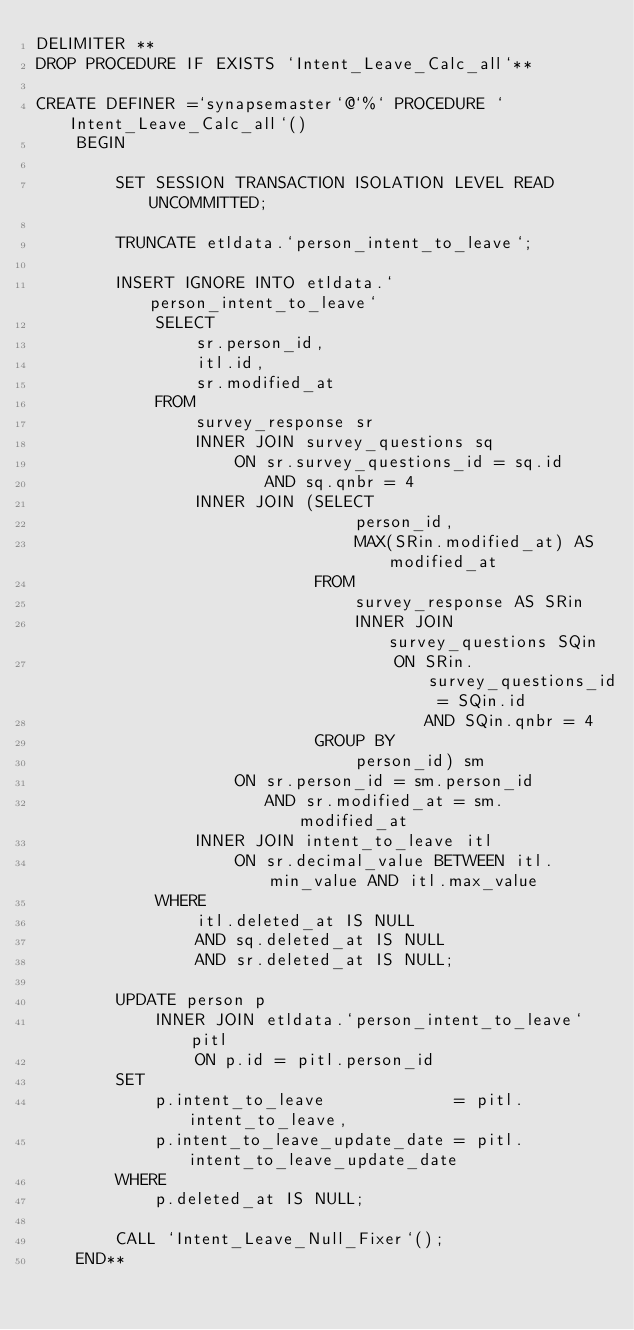Convert code to text. <code><loc_0><loc_0><loc_500><loc_500><_SQL_>DELIMITER **
DROP PROCEDURE IF EXISTS `Intent_Leave_Calc_all`**

CREATE DEFINER =`synapsemaster`@`%` PROCEDURE `Intent_Leave_Calc_all`()
    BEGIN

        SET SESSION TRANSACTION ISOLATION LEVEL READ UNCOMMITTED;

        TRUNCATE etldata.`person_intent_to_leave`;

        INSERT IGNORE INTO etldata.`person_intent_to_leave`
            SELECT
                sr.person_id,
                itl.id,
                sr.modified_at
            FROM
                survey_response sr
                INNER JOIN survey_questions sq
                    ON sr.survey_questions_id = sq.id
                       AND sq.qnbr = 4
                INNER JOIN (SELECT
                                person_id,
                                MAX(SRin.modified_at) AS modified_at
                            FROM
                                survey_response AS SRin
                                INNER JOIN survey_questions SQin
                                    ON SRin.survey_questions_id = SQin.id
                                       AND SQin.qnbr = 4
                            GROUP BY
                                person_id) sm
                    ON sr.person_id = sm.person_id
                       AND sr.modified_at = sm.modified_at
                INNER JOIN intent_to_leave itl
                    ON sr.decimal_value BETWEEN itl.min_value AND itl.max_value
            WHERE
                itl.deleted_at IS NULL
                AND sq.deleted_at IS NULL
                AND sr.deleted_at IS NULL;

        UPDATE person p
            INNER JOIN etldata.`person_intent_to_leave` pitl
                ON p.id = pitl.person_id
        SET
            p.intent_to_leave             = pitl.intent_to_leave,
            p.intent_to_leave_update_date = pitl.intent_to_leave_update_date
        WHERE
            p.deleted_at IS NULL;

        CALL `Intent_Leave_Null_Fixer`();
    END**






</code> 